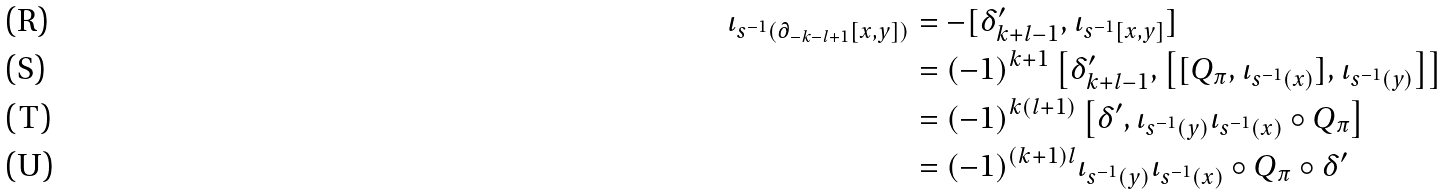<formula> <loc_0><loc_0><loc_500><loc_500>\iota _ { s ^ { - 1 } ( \partial _ { - k - l + 1 } [ x , y ] ) } & = - [ \delta ^ { \prime } _ { k + l - 1 } , \iota _ { s ^ { - 1 } [ x , y ] } ] \\ & = ( - 1 ) ^ { k + 1 } \left [ \delta ^ { \prime } _ { k + l - 1 } , \left [ [ Q _ { \pi } , \iota _ { s ^ { - 1 } ( x ) } ] , \iota _ { s ^ { - 1 } ( y ) } \right ] \right ] \\ & = ( - 1 ) ^ { k ( l + 1 ) } \left [ \delta ^ { \prime } , \iota _ { s ^ { - 1 } ( y ) } \iota _ { s ^ { - 1 } ( x ) } \circ Q _ { \pi } \right ] \\ & = ( - 1 ) ^ { ( k + 1 ) l } \iota _ { s ^ { - 1 } ( y ) } \iota _ { s ^ { - 1 } ( x ) } \circ Q _ { \pi } \circ \delta ^ { \prime }</formula> 